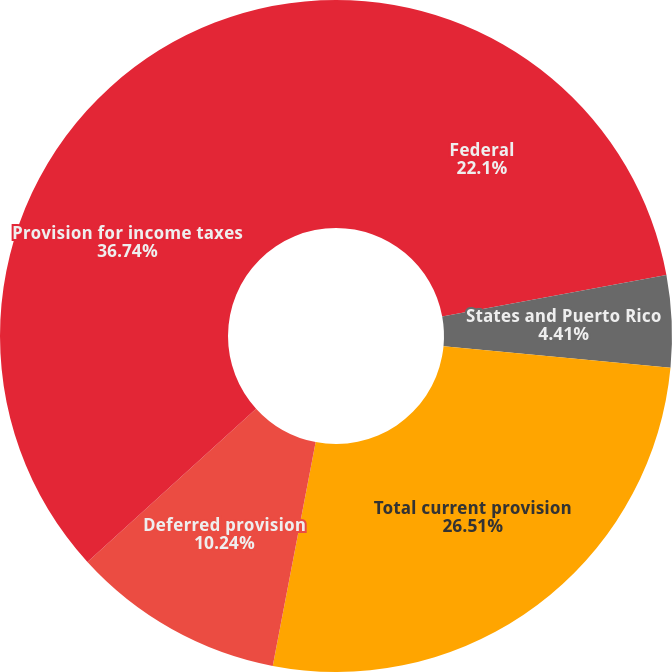<chart> <loc_0><loc_0><loc_500><loc_500><pie_chart><fcel>Federal<fcel>States and Puerto Rico<fcel>Total current provision<fcel>Deferred provision<fcel>Provision for income taxes<nl><fcel>22.1%<fcel>4.41%<fcel>26.51%<fcel>10.24%<fcel>36.75%<nl></chart> 